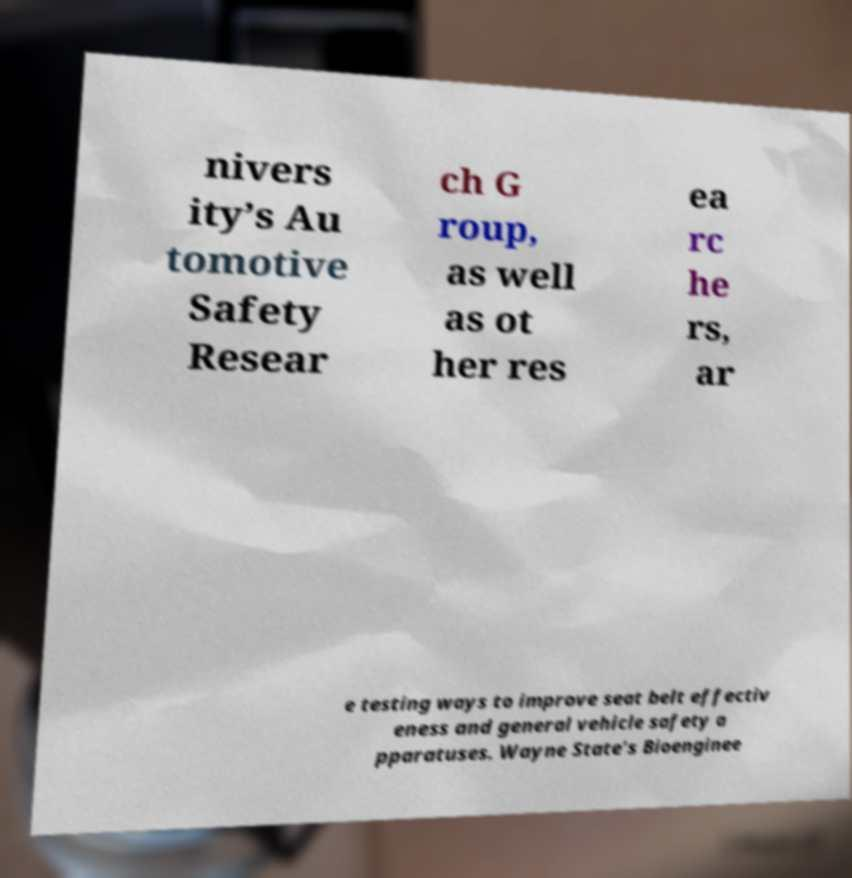Please read and relay the text visible in this image. What does it say? nivers ity’s Au tomotive Safety Resear ch G roup, as well as ot her res ea rc he rs, ar e testing ways to improve seat belt effectiv eness and general vehicle safety a pparatuses. Wayne State’s Bioenginee 